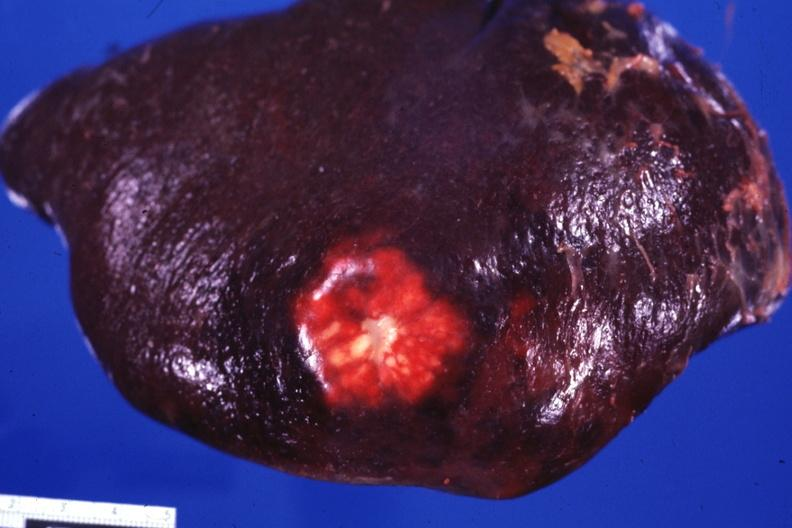what is present?
Answer the question using a single word or phrase. Hematologic 